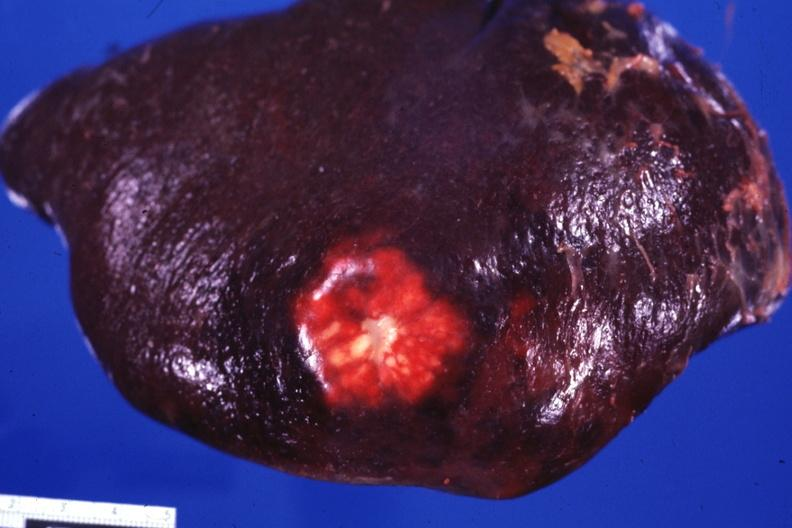what is present?
Answer the question using a single word or phrase. Hematologic 